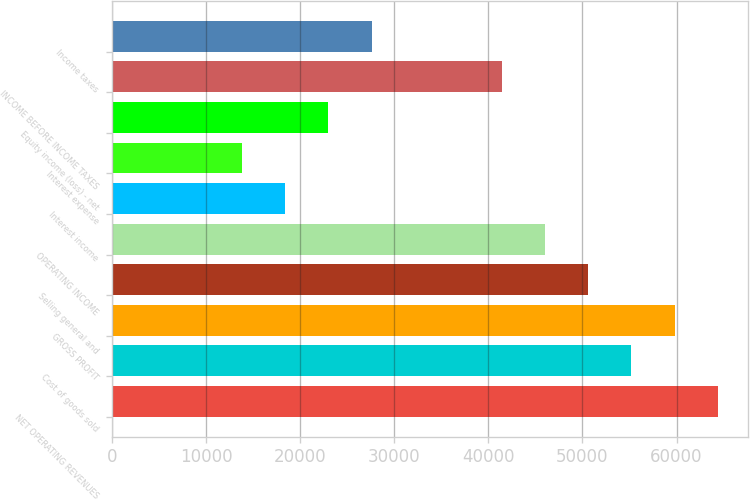Convert chart. <chart><loc_0><loc_0><loc_500><loc_500><bar_chart><fcel>NET OPERATING REVENUES<fcel>Cost of goods sold<fcel>GROSS PROFIT<fcel>Selling general and<fcel>OPERATING INCOME<fcel>Interest income<fcel>Interest expense<fcel>Equity income (loss) - net<fcel>INCOME BEFORE INCOME TAXES<fcel>Income taxes<nl><fcel>64396.6<fcel>55197.3<fcel>59796.9<fcel>50597.6<fcel>45998<fcel>18400.2<fcel>13800.5<fcel>22999.8<fcel>41398.4<fcel>27599.4<nl></chart> 